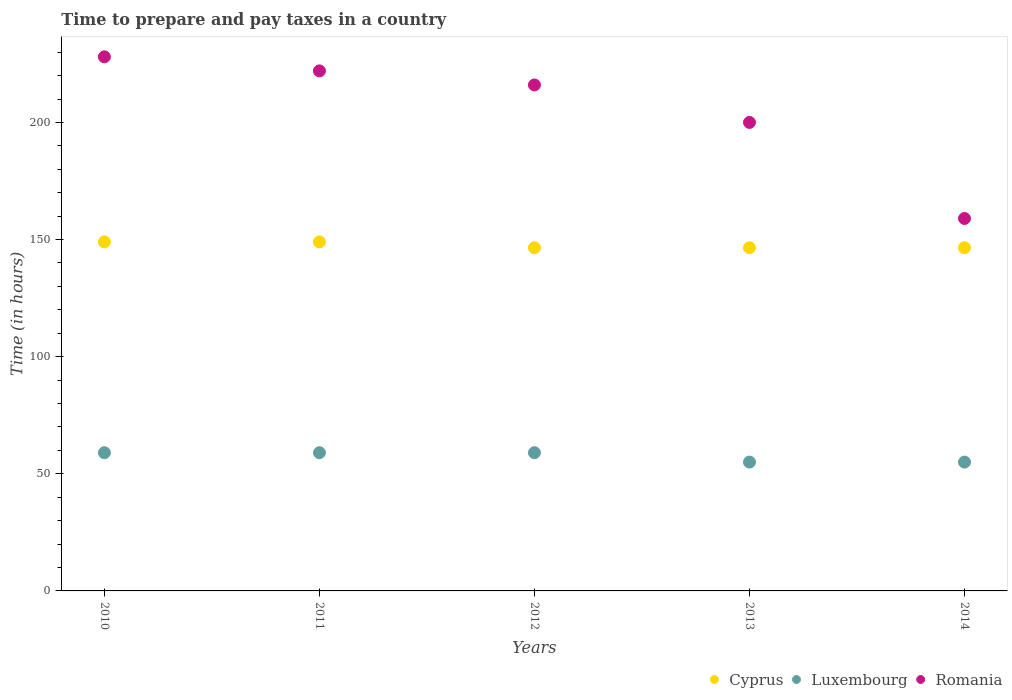How many different coloured dotlines are there?
Your answer should be very brief. 3. Is the number of dotlines equal to the number of legend labels?
Your response must be concise. Yes. What is the number of hours required to prepare and pay taxes in Romania in 2014?
Provide a short and direct response. 159. Across all years, what is the maximum number of hours required to prepare and pay taxes in Luxembourg?
Your answer should be very brief. 59. Across all years, what is the minimum number of hours required to prepare and pay taxes in Cyprus?
Provide a short and direct response. 146.5. What is the total number of hours required to prepare and pay taxes in Romania in the graph?
Offer a very short reply. 1025. What is the difference between the number of hours required to prepare and pay taxes in Cyprus in 2013 and that in 2014?
Keep it short and to the point. 0. What is the difference between the number of hours required to prepare and pay taxes in Luxembourg in 2010 and the number of hours required to prepare and pay taxes in Romania in 2012?
Offer a terse response. -157. What is the average number of hours required to prepare and pay taxes in Romania per year?
Provide a succinct answer. 205. In the year 2013, what is the difference between the number of hours required to prepare and pay taxes in Cyprus and number of hours required to prepare and pay taxes in Luxembourg?
Your response must be concise. 91.5. In how many years, is the number of hours required to prepare and pay taxes in Romania greater than 90 hours?
Make the answer very short. 5. What is the ratio of the number of hours required to prepare and pay taxes in Cyprus in 2011 to that in 2014?
Offer a very short reply. 1.02. Is it the case that in every year, the sum of the number of hours required to prepare and pay taxes in Romania and number of hours required to prepare and pay taxes in Luxembourg  is greater than the number of hours required to prepare and pay taxes in Cyprus?
Offer a very short reply. Yes. How many years are there in the graph?
Provide a short and direct response. 5. Are the values on the major ticks of Y-axis written in scientific E-notation?
Your response must be concise. No. Does the graph contain grids?
Your answer should be very brief. No. What is the title of the graph?
Make the answer very short. Time to prepare and pay taxes in a country. What is the label or title of the X-axis?
Make the answer very short. Years. What is the label or title of the Y-axis?
Provide a short and direct response. Time (in hours). What is the Time (in hours) in Cyprus in 2010?
Offer a very short reply. 149. What is the Time (in hours) of Romania in 2010?
Your response must be concise. 228. What is the Time (in hours) in Cyprus in 2011?
Offer a terse response. 149. What is the Time (in hours) of Romania in 2011?
Ensure brevity in your answer.  222. What is the Time (in hours) in Cyprus in 2012?
Offer a very short reply. 146.5. What is the Time (in hours) of Luxembourg in 2012?
Provide a short and direct response. 59. What is the Time (in hours) in Romania in 2012?
Your response must be concise. 216. What is the Time (in hours) of Cyprus in 2013?
Offer a terse response. 146.5. What is the Time (in hours) of Luxembourg in 2013?
Ensure brevity in your answer.  55. What is the Time (in hours) of Romania in 2013?
Keep it short and to the point. 200. What is the Time (in hours) in Cyprus in 2014?
Offer a terse response. 146.5. What is the Time (in hours) of Romania in 2014?
Give a very brief answer. 159. Across all years, what is the maximum Time (in hours) of Cyprus?
Make the answer very short. 149. Across all years, what is the maximum Time (in hours) of Romania?
Offer a terse response. 228. Across all years, what is the minimum Time (in hours) in Cyprus?
Your response must be concise. 146.5. Across all years, what is the minimum Time (in hours) in Romania?
Make the answer very short. 159. What is the total Time (in hours) of Cyprus in the graph?
Make the answer very short. 737.5. What is the total Time (in hours) in Luxembourg in the graph?
Offer a very short reply. 287. What is the total Time (in hours) of Romania in the graph?
Ensure brevity in your answer.  1025. What is the difference between the Time (in hours) in Cyprus in 2010 and that in 2011?
Ensure brevity in your answer.  0. What is the difference between the Time (in hours) of Cyprus in 2010 and that in 2012?
Your answer should be very brief. 2.5. What is the difference between the Time (in hours) of Romania in 2010 and that in 2012?
Offer a terse response. 12. What is the difference between the Time (in hours) in Cyprus in 2010 and that in 2013?
Provide a short and direct response. 2.5. What is the difference between the Time (in hours) in Luxembourg in 2010 and that in 2013?
Keep it short and to the point. 4. What is the difference between the Time (in hours) in Romania in 2010 and that in 2014?
Your answer should be compact. 69. What is the difference between the Time (in hours) in Cyprus in 2011 and that in 2012?
Your answer should be very brief. 2.5. What is the difference between the Time (in hours) of Luxembourg in 2011 and that in 2012?
Your answer should be very brief. 0. What is the difference between the Time (in hours) in Cyprus in 2011 and that in 2014?
Ensure brevity in your answer.  2.5. What is the difference between the Time (in hours) in Luxembourg in 2011 and that in 2014?
Provide a short and direct response. 4. What is the difference between the Time (in hours) in Cyprus in 2012 and that in 2013?
Offer a very short reply. 0. What is the difference between the Time (in hours) in Luxembourg in 2012 and that in 2013?
Ensure brevity in your answer.  4. What is the difference between the Time (in hours) in Romania in 2012 and that in 2013?
Give a very brief answer. 16. What is the difference between the Time (in hours) in Cyprus in 2012 and that in 2014?
Make the answer very short. 0. What is the difference between the Time (in hours) in Luxembourg in 2012 and that in 2014?
Ensure brevity in your answer.  4. What is the difference between the Time (in hours) in Romania in 2013 and that in 2014?
Your answer should be compact. 41. What is the difference between the Time (in hours) in Cyprus in 2010 and the Time (in hours) in Luxembourg in 2011?
Your answer should be compact. 90. What is the difference between the Time (in hours) of Cyprus in 2010 and the Time (in hours) of Romania in 2011?
Your response must be concise. -73. What is the difference between the Time (in hours) of Luxembourg in 2010 and the Time (in hours) of Romania in 2011?
Offer a very short reply. -163. What is the difference between the Time (in hours) of Cyprus in 2010 and the Time (in hours) of Romania in 2012?
Provide a succinct answer. -67. What is the difference between the Time (in hours) in Luxembourg in 2010 and the Time (in hours) in Romania in 2012?
Give a very brief answer. -157. What is the difference between the Time (in hours) in Cyprus in 2010 and the Time (in hours) in Luxembourg in 2013?
Your answer should be very brief. 94. What is the difference between the Time (in hours) in Cyprus in 2010 and the Time (in hours) in Romania in 2013?
Offer a very short reply. -51. What is the difference between the Time (in hours) in Luxembourg in 2010 and the Time (in hours) in Romania in 2013?
Provide a succinct answer. -141. What is the difference between the Time (in hours) in Cyprus in 2010 and the Time (in hours) in Luxembourg in 2014?
Make the answer very short. 94. What is the difference between the Time (in hours) of Cyprus in 2010 and the Time (in hours) of Romania in 2014?
Give a very brief answer. -10. What is the difference between the Time (in hours) in Luxembourg in 2010 and the Time (in hours) in Romania in 2014?
Offer a very short reply. -100. What is the difference between the Time (in hours) in Cyprus in 2011 and the Time (in hours) in Luxembourg in 2012?
Your response must be concise. 90. What is the difference between the Time (in hours) in Cyprus in 2011 and the Time (in hours) in Romania in 2012?
Your answer should be very brief. -67. What is the difference between the Time (in hours) of Luxembourg in 2011 and the Time (in hours) of Romania in 2012?
Your answer should be very brief. -157. What is the difference between the Time (in hours) of Cyprus in 2011 and the Time (in hours) of Luxembourg in 2013?
Ensure brevity in your answer.  94. What is the difference between the Time (in hours) in Cyprus in 2011 and the Time (in hours) in Romania in 2013?
Provide a short and direct response. -51. What is the difference between the Time (in hours) of Luxembourg in 2011 and the Time (in hours) of Romania in 2013?
Offer a very short reply. -141. What is the difference between the Time (in hours) of Cyprus in 2011 and the Time (in hours) of Luxembourg in 2014?
Offer a very short reply. 94. What is the difference between the Time (in hours) in Luxembourg in 2011 and the Time (in hours) in Romania in 2014?
Ensure brevity in your answer.  -100. What is the difference between the Time (in hours) of Cyprus in 2012 and the Time (in hours) of Luxembourg in 2013?
Offer a very short reply. 91.5. What is the difference between the Time (in hours) in Cyprus in 2012 and the Time (in hours) in Romania in 2013?
Keep it short and to the point. -53.5. What is the difference between the Time (in hours) in Luxembourg in 2012 and the Time (in hours) in Romania in 2013?
Provide a succinct answer. -141. What is the difference between the Time (in hours) of Cyprus in 2012 and the Time (in hours) of Luxembourg in 2014?
Ensure brevity in your answer.  91.5. What is the difference between the Time (in hours) in Luxembourg in 2012 and the Time (in hours) in Romania in 2014?
Provide a short and direct response. -100. What is the difference between the Time (in hours) in Cyprus in 2013 and the Time (in hours) in Luxembourg in 2014?
Give a very brief answer. 91.5. What is the difference between the Time (in hours) of Luxembourg in 2013 and the Time (in hours) of Romania in 2014?
Your response must be concise. -104. What is the average Time (in hours) of Cyprus per year?
Provide a succinct answer. 147.5. What is the average Time (in hours) of Luxembourg per year?
Keep it short and to the point. 57.4. What is the average Time (in hours) in Romania per year?
Provide a succinct answer. 205. In the year 2010, what is the difference between the Time (in hours) in Cyprus and Time (in hours) in Romania?
Give a very brief answer. -79. In the year 2010, what is the difference between the Time (in hours) in Luxembourg and Time (in hours) in Romania?
Your answer should be very brief. -169. In the year 2011, what is the difference between the Time (in hours) of Cyprus and Time (in hours) of Romania?
Offer a very short reply. -73. In the year 2011, what is the difference between the Time (in hours) of Luxembourg and Time (in hours) of Romania?
Provide a short and direct response. -163. In the year 2012, what is the difference between the Time (in hours) in Cyprus and Time (in hours) in Luxembourg?
Make the answer very short. 87.5. In the year 2012, what is the difference between the Time (in hours) in Cyprus and Time (in hours) in Romania?
Your answer should be compact. -69.5. In the year 2012, what is the difference between the Time (in hours) in Luxembourg and Time (in hours) in Romania?
Provide a short and direct response. -157. In the year 2013, what is the difference between the Time (in hours) in Cyprus and Time (in hours) in Luxembourg?
Make the answer very short. 91.5. In the year 2013, what is the difference between the Time (in hours) in Cyprus and Time (in hours) in Romania?
Provide a succinct answer. -53.5. In the year 2013, what is the difference between the Time (in hours) in Luxembourg and Time (in hours) in Romania?
Ensure brevity in your answer.  -145. In the year 2014, what is the difference between the Time (in hours) of Cyprus and Time (in hours) of Luxembourg?
Keep it short and to the point. 91.5. In the year 2014, what is the difference between the Time (in hours) of Cyprus and Time (in hours) of Romania?
Make the answer very short. -12.5. In the year 2014, what is the difference between the Time (in hours) of Luxembourg and Time (in hours) of Romania?
Make the answer very short. -104. What is the ratio of the Time (in hours) in Cyprus in 2010 to that in 2011?
Ensure brevity in your answer.  1. What is the ratio of the Time (in hours) of Romania in 2010 to that in 2011?
Provide a short and direct response. 1.03. What is the ratio of the Time (in hours) in Cyprus in 2010 to that in 2012?
Keep it short and to the point. 1.02. What is the ratio of the Time (in hours) of Romania in 2010 to that in 2012?
Ensure brevity in your answer.  1.06. What is the ratio of the Time (in hours) in Cyprus in 2010 to that in 2013?
Give a very brief answer. 1.02. What is the ratio of the Time (in hours) of Luxembourg in 2010 to that in 2013?
Provide a succinct answer. 1.07. What is the ratio of the Time (in hours) of Romania in 2010 to that in 2013?
Keep it short and to the point. 1.14. What is the ratio of the Time (in hours) in Cyprus in 2010 to that in 2014?
Ensure brevity in your answer.  1.02. What is the ratio of the Time (in hours) of Luxembourg in 2010 to that in 2014?
Make the answer very short. 1.07. What is the ratio of the Time (in hours) in Romania in 2010 to that in 2014?
Give a very brief answer. 1.43. What is the ratio of the Time (in hours) of Cyprus in 2011 to that in 2012?
Offer a terse response. 1.02. What is the ratio of the Time (in hours) in Luxembourg in 2011 to that in 2012?
Your answer should be compact. 1. What is the ratio of the Time (in hours) of Romania in 2011 to that in 2012?
Ensure brevity in your answer.  1.03. What is the ratio of the Time (in hours) of Cyprus in 2011 to that in 2013?
Keep it short and to the point. 1.02. What is the ratio of the Time (in hours) of Luxembourg in 2011 to that in 2013?
Your answer should be compact. 1.07. What is the ratio of the Time (in hours) of Romania in 2011 to that in 2013?
Make the answer very short. 1.11. What is the ratio of the Time (in hours) in Cyprus in 2011 to that in 2014?
Your response must be concise. 1.02. What is the ratio of the Time (in hours) in Luxembourg in 2011 to that in 2014?
Offer a very short reply. 1.07. What is the ratio of the Time (in hours) of Romania in 2011 to that in 2014?
Provide a succinct answer. 1.4. What is the ratio of the Time (in hours) in Cyprus in 2012 to that in 2013?
Keep it short and to the point. 1. What is the ratio of the Time (in hours) in Luxembourg in 2012 to that in 2013?
Offer a very short reply. 1.07. What is the ratio of the Time (in hours) in Romania in 2012 to that in 2013?
Provide a short and direct response. 1.08. What is the ratio of the Time (in hours) of Cyprus in 2012 to that in 2014?
Offer a terse response. 1. What is the ratio of the Time (in hours) in Luxembourg in 2012 to that in 2014?
Offer a very short reply. 1.07. What is the ratio of the Time (in hours) of Romania in 2012 to that in 2014?
Your answer should be very brief. 1.36. What is the ratio of the Time (in hours) of Romania in 2013 to that in 2014?
Your answer should be compact. 1.26. What is the difference between the highest and the second highest Time (in hours) of Luxembourg?
Give a very brief answer. 0. What is the difference between the highest and the lowest Time (in hours) in Cyprus?
Offer a very short reply. 2.5. What is the difference between the highest and the lowest Time (in hours) in Luxembourg?
Ensure brevity in your answer.  4. What is the difference between the highest and the lowest Time (in hours) in Romania?
Make the answer very short. 69. 